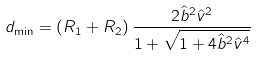Convert formula to latex. <formula><loc_0><loc_0><loc_500><loc_500>d _ { \min } = ( R _ { 1 } + R _ { 2 } ) \, \frac { 2 \hat { b } ^ { 2 } \hat { v } ^ { 2 } } { 1 + \sqrt { 1 + 4 \hat { b } ^ { 2 } \hat { v } ^ { 4 } } }</formula> 